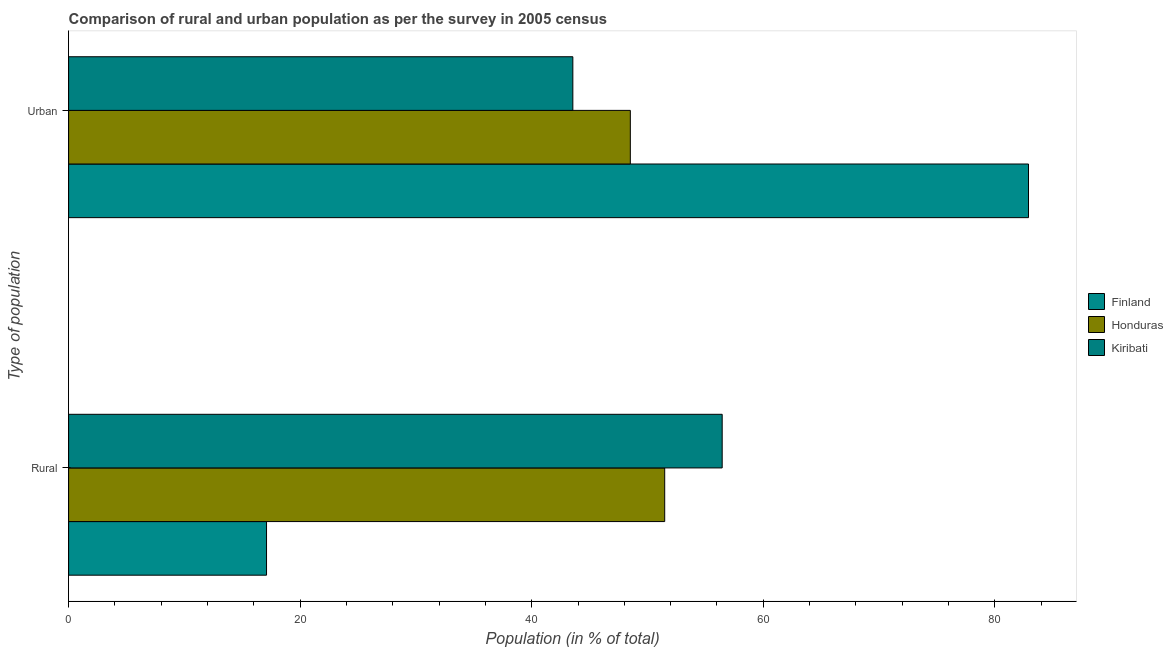Are the number of bars on each tick of the Y-axis equal?
Offer a very short reply. Yes. How many bars are there on the 2nd tick from the bottom?
Give a very brief answer. 3. What is the label of the 1st group of bars from the top?
Provide a succinct answer. Urban. What is the urban population in Kiribati?
Offer a very short reply. 43.55. Across all countries, what is the maximum urban population?
Offer a terse response. 82.91. Across all countries, what is the minimum urban population?
Provide a short and direct response. 43.55. In which country was the rural population maximum?
Provide a succinct answer. Kiribati. In which country was the urban population minimum?
Provide a succinct answer. Kiribati. What is the total urban population in the graph?
Offer a terse response. 174.97. What is the difference between the urban population in Kiribati and that in Honduras?
Your answer should be compact. -4.97. What is the difference between the rural population in Honduras and the urban population in Finland?
Ensure brevity in your answer.  -31.42. What is the average rural population per country?
Provide a succinct answer. 41.68. What is the difference between the rural population and urban population in Finland?
Ensure brevity in your answer.  -65.81. What is the ratio of the rural population in Finland to that in Honduras?
Your answer should be compact. 0.33. Is the urban population in Kiribati less than that in Finland?
Make the answer very short. Yes. In how many countries, is the urban population greater than the average urban population taken over all countries?
Provide a succinct answer. 1. What does the 1st bar from the bottom in Urban represents?
Give a very brief answer. Finland. Does the graph contain grids?
Offer a terse response. No. Where does the legend appear in the graph?
Your response must be concise. Center right. How many legend labels are there?
Give a very brief answer. 3. What is the title of the graph?
Your response must be concise. Comparison of rural and urban population as per the survey in 2005 census. What is the label or title of the X-axis?
Provide a succinct answer. Population (in % of total). What is the label or title of the Y-axis?
Ensure brevity in your answer.  Type of population. What is the Population (in % of total) of Finland in Rural?
Make the answer very short. 17.09. What is the Population (in % of total) of Honduras in Rural?
Give a very brief answer. 51.48. What is the Population (in % of total) of Kiribati in Rural?
Provide a short and direct response. 56.45. What is the Population (in % of total) in Finland in Urban?
Ensure brevity in your answer.  82.91. What is the Population (in % of total) in Honduras in Urban?
Provide a succinct answer. 48.52. What is the Population (in % of total) in Kiribati in Urban?
Offer a very short reply. 43.55. Across all Type of population, what is the maximum Population (in % of total) of Finland?
Ensure brevity in your answer.  82.91. Across all Type of population, what is the maximum Population (in % of total) in Honduras?
Offer a very short reply. 51.48. Across all Type of population, what is the maximum Population (in % of total) of Kiribati?
Offer a terse response. 56.45. Across all Type of population, what is the minimum Population (in % of total) of Finland?
Keep it short and to the point. 17.09. Across all Type of population, what is the minimum Population (in % of total) of Honduras?
Provide a short and direct response. 48.52. Across all Type of population, what is the minimum Population (in % of total) in Kiribati?
Provide a short and direct response. 43.55. What is the difference between the Population (in % of total) in Finland in Rural and that in Urban?
Offer a very short reply. -65.81. What is the difference between the Population (in % of total) in Honduras in Rural and that in Urban?
Ensure brevity in your answer.  2.97. What is the difference between the Population (in % of total) in Kiribati in Rural and that in Urban?
Ensure brevity in your answer.  12.9. What is the difference between the Population (in % of total) of Finland in Rural and the Population (in % of total) of Honduras in Urban?
Offer a very short reply. -31.42. What is the difference between the Population (in % of total) in Finland in Rural and the Population (in % of total) in Kiribati in Urban?
Give a very brief answer. -26.46. What is the difference between the Population (in % of total) of Honduras in Rural and the Population (in % of total) of Kiribati in Urban?
Provide a succinct answer. 7.93. What is the average Population (in % of total) of Honduras per Type of population?
Your response must be concise. 50. What is the difference between the Population (in % of total) of Finland and Population (in % of total) of Honduras in Rural?
Your answer should be compact. -34.39. What is the difference between the Population (in % of total) in Finland and Population (in % of total) in Kiribati in Rural?
Keep it short and to the point. -39.35. What is the difference between the Population (in % of total) of Honduras and Population (in % of total) of Kiribati in Rural?
Your answer should be very brief. -4.96. What is the difference between the Population (in % of total) of Finland and Population (in % of total) of Honduras in Urban?
Make the answer very short. 34.39. What is the difference between the Population (in % of total) of Finland and Population (in % of total) of Kiribati in Urban?
Provide a succinct answer. 39.35. What is the difference between the Population (in % of total) in Honduras and Population (in % of total) in Kiribati in Urban?
Provide a short and direct response. 4.96. What is the ratio of the Population (in % of total) in Finland in Rural to that in Urban?
Your response must be concise. 0.21. What is the ratio of the Population (in % of total) in Honduras in Rural to that in Urban?
Keep it short and to the point. 1.06. What is the ratio of the Population (in % of total) of Kiribati in Rural to that in Urban?
Make the answer very short. 1.3. What is the difference between the highest and the second highest Population (in % of total) in Finland?
Your response must be concise. 65.81. What is the difference between the highest and the second highest Population (in % of total) in Honduras?
Provide a short and direct response. 2.97. What is the difference between the highest and the second highest Population (in % of total) in Kiribati?
Provide a short and direct response. 12.9. What is the difference between the highest and the lowest Population (in % of total) in Finland?
Your answer should be very brief. 65.81. What is the difference between the highest and the lowest Population (in % of total) in Honduras?
Ensure brevity in your answer.  2.97. What is the difference between the highest and the lowest Population (in % of total) in Kiribati?
Your response must be concise. 12.9. 